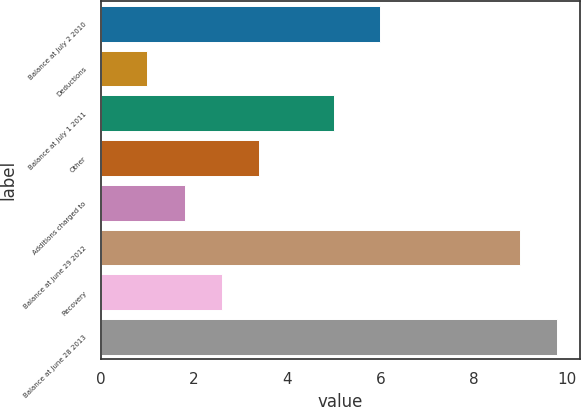<chart> <loc_0><loc_0><loc_500><loc_500><bar_chart><fcel>Balance at July 2 2010<fcel>Deductions<fcel>Balance at July 1 2011<fcel>Other<fcel>Additions charged to<fcel>Balance at June 29 2012<fcel>Recovery<fcel>Balance at June 28 2013<nl><fcel>6<fcel>1<fcel>5<fcel>3.4<fcel>1.8<fcel>9<fcel>2.6<fcel>9.8<nl></chart> 